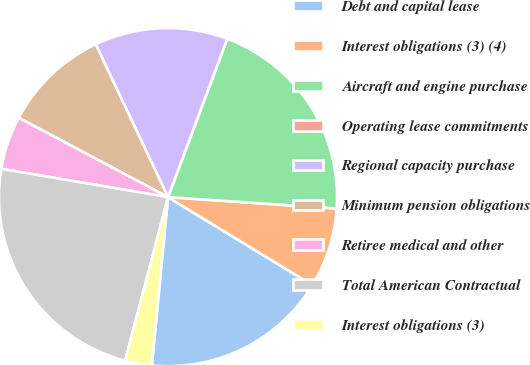<chart> <loc_0><loc_0><loc_500><loc_500><pie_chart><fcel>Debt and capital lease<fcel>Interest obligations (3) (4)<fcel>Aircraft and engine purchase<fcel>Operating lease commitments<fcel>Regional capacity purchase<fcel>Minimum pension obligations<fcel>Retiree medical and other<fcel>Total American Contractual<fcel>Interest obligations (3)<nl><fcel>17.82%<fcel>7.64%<fcel>20.37%<fcel>0.0%<fcel>12.73%<fcel>10.19%<fcel>5.1%<fcel>23.6%<fcel>2.55%<nl></chart> 